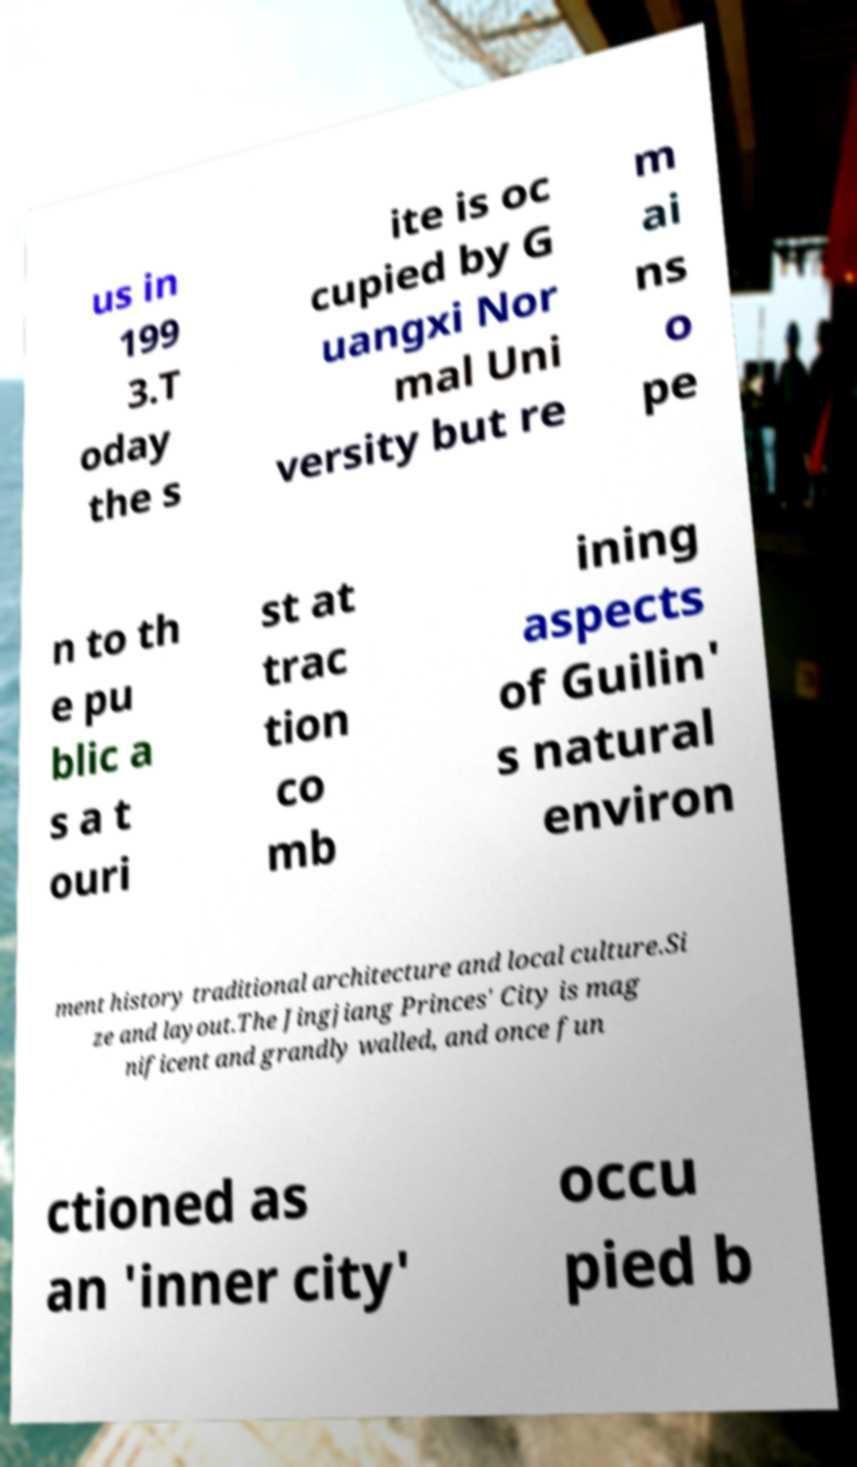Can you read and provide the text displayed in the image?This photo seems to have some interesting text. Can you extract and type it out for me? us in 199 3.T oday the s ite is oc cupied by G uangxi Nor mal Uni versity but re m ai ns o pe n to th e pu blic a s a t ouri st at trac tion co mb ining aspects of Guilin' s natural environ ment history traditional architecture and local culture.Si ze and layout.The Jingjiang Princes' City is mag nificent and grandly walled, and once fun ctioned as an 'inner city' occu pied b 